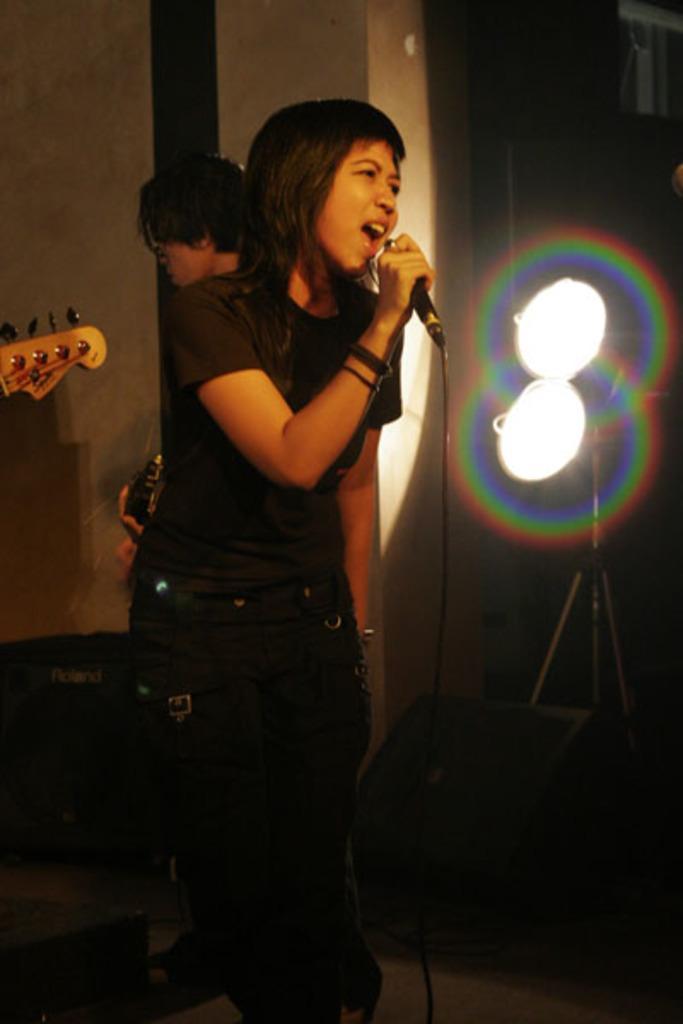Could you give a brief overview of what you see in this image? Here we can see that a woman is standing on the floor and holding a microphone in her hand, and at back a person is standing, and here are the lights. 